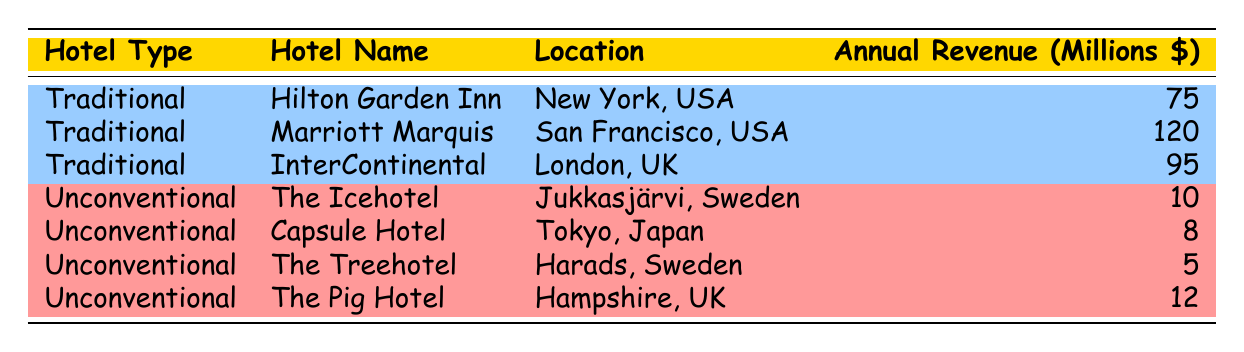What is the annual revenue of the Marriott Marquis? The table lists the annual revenue of the Marriott Marquis under the Traditional Hotel category, showing it to be 120 million dollars.
Answer: 120 million Which unconventional hotel has the highest annual revenue? From the table, we can see the annual revenues for The Icehotel (10 million), Capsule Hotel (8 million), The Treehotel (5 million), and The Pig Hotel (12 million). The Pig Hotel has the highest annual revenue at 12 million dollars.
Answer: The Pig Hotel What is the total annual revenue of all traditional hotels? To find the total for traditional hotels, we add their annual revenues: Hilton Garden Inn (75 million) + Marriott Marquis (120 million) + InterContinental (95 million) = 75 + 120 + 95 = 290 million.
Answer: 290 million Is it true that all unconventional hotels have an annual revenue above 10 million dollars? Looking at the revenues, The Icehotel is 10 million, Capsule Hotel is 8 million, The Treehotel is 5 million, and The Pig Hotel is 12 million. Since The Icehotel is exactly 10 million and Capsule Hotel and The Treehotel are below that, the statement is false.
Answer: No What is the average annual revenue of unconventional hotels? The revenues for unconventional hotels are 10 million (The Icehotel), 8 million (Capsule Hotel), 5 million (The Treehotel), and 12 million (The Pig Hotel). To find the average, we first sum them up: 10 + 8 + 5 + 12 = 35 million. There are 4 unconventional hotels, so the average is 35 million / 4 = 8.75 million.
Answer: 8.75 million Which location has the hotel with the lowest annual revenue? The hotels with the lowest revenues are Capsule Hotel in Tokyo (8 million), The Treehotel in Harads (5 million), and The Pig Hotel in Hampshire (12 million). The Treehotel has the lowest revenue of 5 million and is located in Harads, Sweden.
Answer: Harads, Sweden What is the revenue difference between the highest and lowest earning traditional hotels? The highest earning traditional hotel is Marriott Marquis with 120 million, and the lowest is Hilton Garden Inn with 75 million. The difference is 120 million - 75 million = 45 million.
Answer: 45 million Are all hotels listed in the table located in cities? The hotels listed include The Icehotel, which is located in Jukkasjärvi, a village rather than a city. Therefore, the statement is false as not all listings are in cities.
Answer: No 